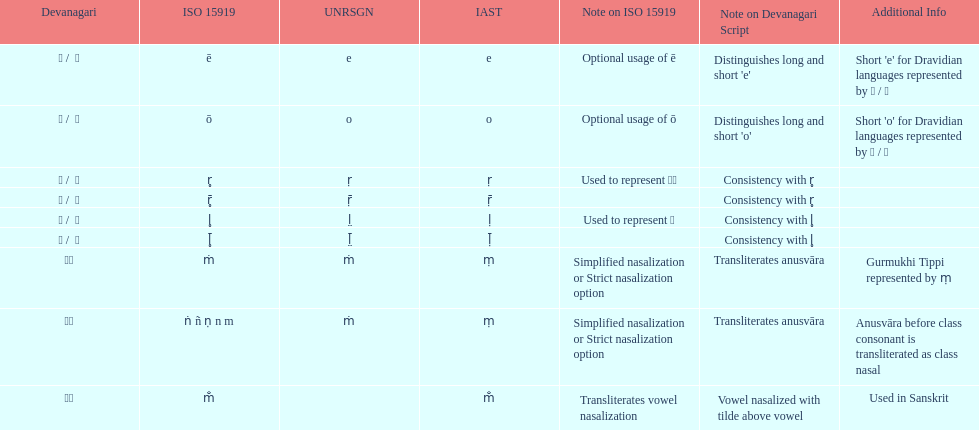How many total options are there about anusvara? 2. 